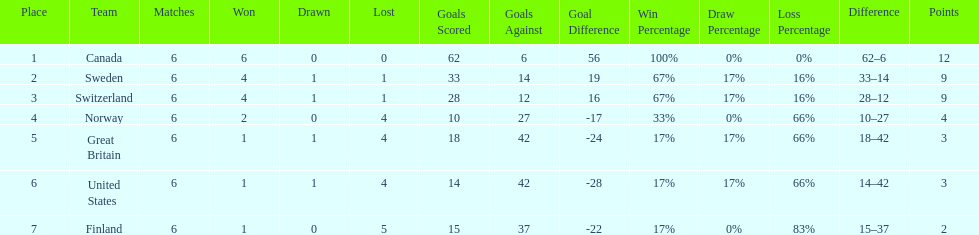What was the number of points won by great britain? 3. 